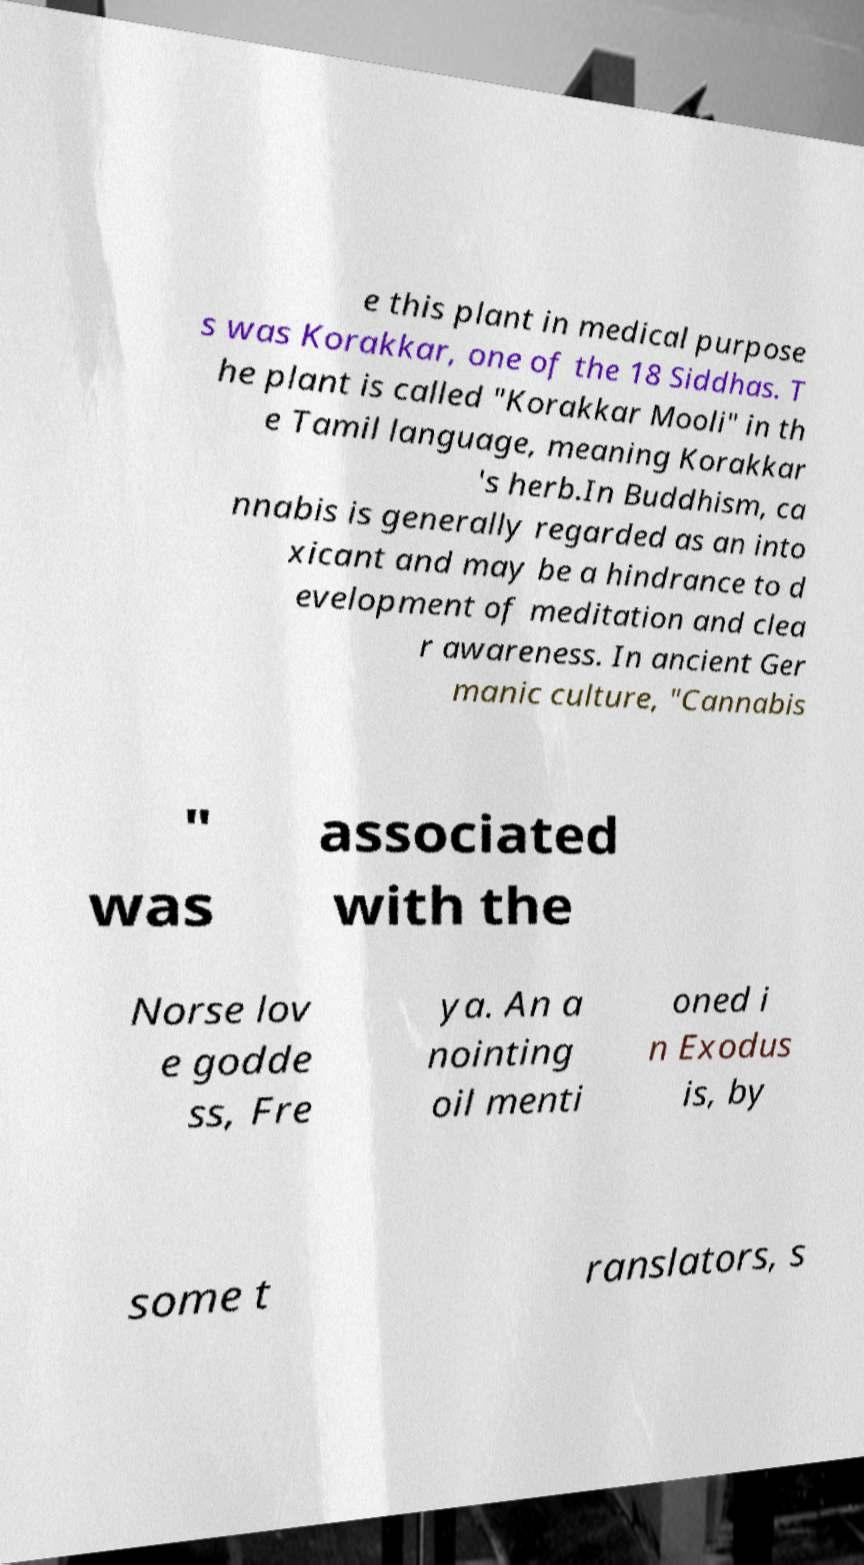Could you assist in decoding the text presented in this image and type it out clearly? e this plant in medical purpose s was Korakkar, one of the 18 Siddhas. T he plant is called "Korakkar Mooli" in th e Tamil language, meaning Korakkar 's herb.In Buddhism, ca nnabis is generally regarded as an into xicant and may be a hindrance to d evelopment of meditation and clea r awareness. In ancient Ger manic culture, "Cannabis " was associated with the Norse lov e godde ss, Fre ya. An a nointing oil menti oned i n Exodus is, by some t ranslators, s 